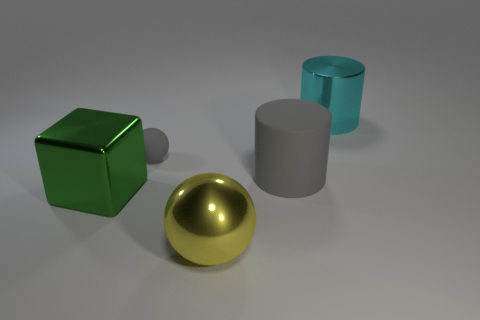What size is the gray object on the right side of the tiny gray rubber sphere?
Offer a terse response. Large. There is a cylinder that is in front of the big thing that is right of the big matte thing; how big is it?
Give a very brief answer. Large. There is a cyan thing that is the same size as the rubber cylinder; what is its material?
Your answer should be very brief. Metal. Are there any yellow balls behind the yellow thing?
Your response must be concise. No. Are there the same number of cylinders left of the yellow thing and large metallic cylinders?
Offer a very short reply. No. What is the shape of the gray thing that is the same size as the green object?
Ensure brevity in your answer.  Cylinder. What material is the yellow object?
Your answer should be very brief. Metal. What is the color of the large thing that is both in front of the small matte thing and on the right side of the yellow sphere?
Offer a very short reply. Gray. Are there an equal number of green things that are behind the green shiny cube and gray matte cylinders left of the small object?
Provide a succinct answer. Yes. There is a small object that is the same material as the gray cylinder; what color is it?
Your answer should be compact. Gray. 